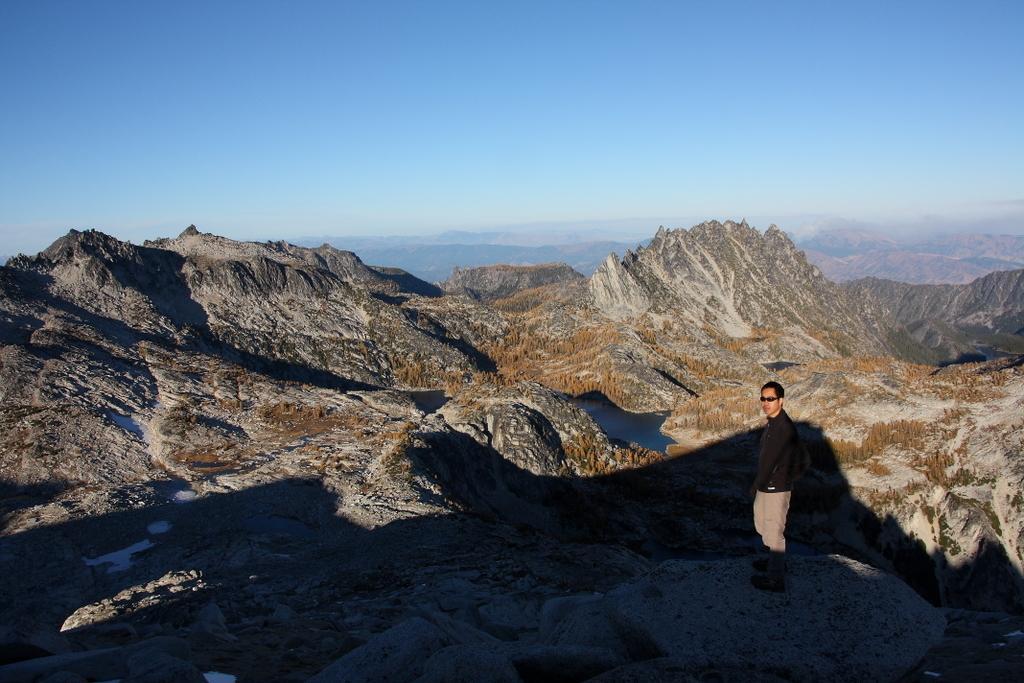Can you describe this image briefly? To the right side of the image there is a person. In the background of the image there are mountains. At the top of the image there is sky. 